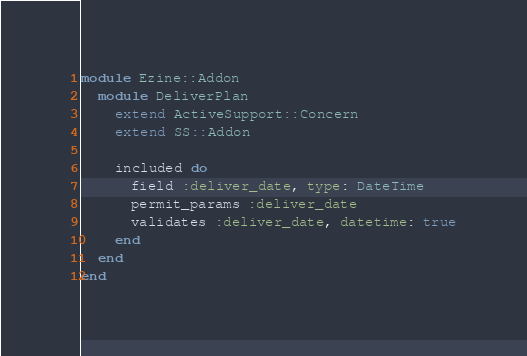Convert code to text. <code><loc_0><loc_0><loc_500><loc_500><_Ruby_>module Ezine::Addon
  module DeliverPlan
    extend ActiveSupport::Concern
    extend SS::Addon

    included do
      field :deliver_date, type: DateTime
      permit_params :deliver_date
      validates :deliver_date, datetime: true
    end
  end
end
</code> 